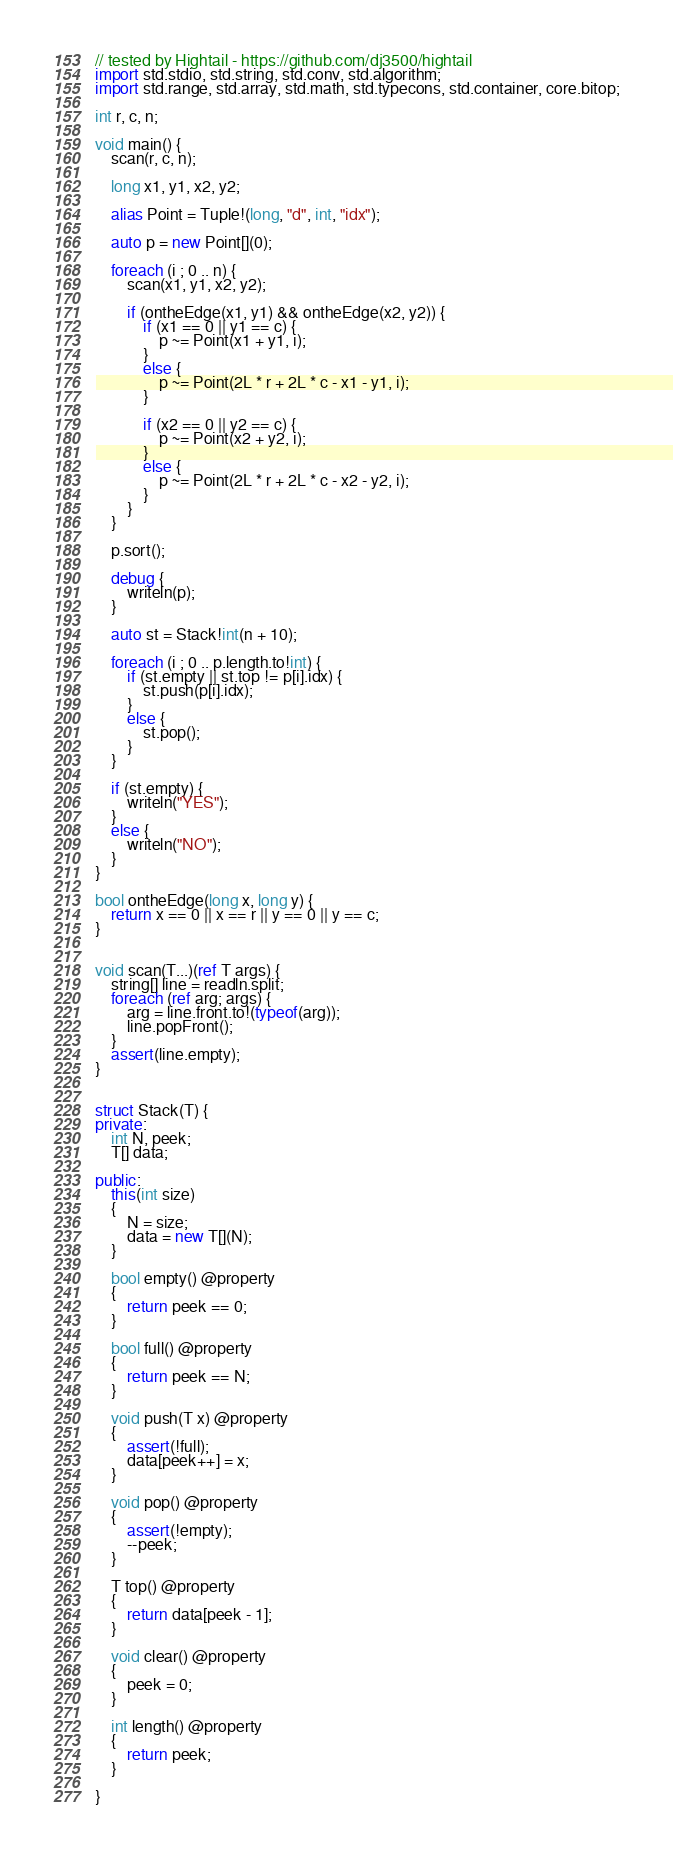Convert code to text. <code><loc_0><loc_0><loc_500><loc_500><_D_>// tested by Hightail - https://github.com/dj3500/hightail
import std.stdio, std.string, std.conv, std.algorithm;
import std.range, std.array, std.math, std.typecons, std.container, core.bitop;

int r, c, n;

void main() {
    scan(r, c, n);

    long x1, y1, x2, y2;

    alias Point = Tuple!(long, "d", int, "idx");

    auto p = new Point[](0);

    foreach (i ; 0 .. n) {
        scan(x1, y1, x2, y2);

        if (ontheEdge(x1, y1) && ontheEdge(x2, y2)) {
            if (x1 == 0 || y1 == c) {
                p ~= Point(x1 + y1, i);
            }
            else {
                p ~= Point(2L * r + 2L * c - x1 - y1, i);
            }

            if (x2 == 0 || y2 == c) {
                p ~= Point(x2 + y2, i);
            }
            else {
                p ~= Point(2L * r + 2L * c - x2 - y2, i);
            }
        }
    }

    p.sort();

    debug {
        writeln(p);
    }

    auto st = Stack!int(n + 10);

    foreach (i ; 0 .. p.length.to!int) {
        if (st.empty || st.top != p[i].idx) {
            st.push(p[i].idx);
        }
        else {
            st.pop();
        }
    }

    if (st.empty) {
        writeln("YES");
    }
    else {
        writeln("NO");
    }
}

bool ontheEdge(long x, long y) {
    return x == 0 || x == r || y == 0 || y == c;
}


void scan(T...)(ref T args) {
    string[] line = readln.split;
    foreach (ref arg; args) {
        arg = line.front.to!(typeof(arg));
        line.popFront();
    }
    assert(line.empty);
}


struct Stack(T) {
private:
    int N, peek;
    T[] data;

public:
    this(int size) 
    {
        N = size;
        data = new T[](N);
    }

    bool empty() @property
    {
        return peek == 0;
    }

    bool full() @property
    {
        return peek == N;
    }

    void push(T x) @property
    {
        assert(!full);
        data[peek++] = x;
    }

    void pop() @property
    {
        assert(!empty);
        --peek;
    }

    T top() @property
    {
        return data[peek - 1];
    }

    void clear() @property
    {
        peek = 0;
    }

    int length() @property
    {
        return peek;
    }

}</code> 